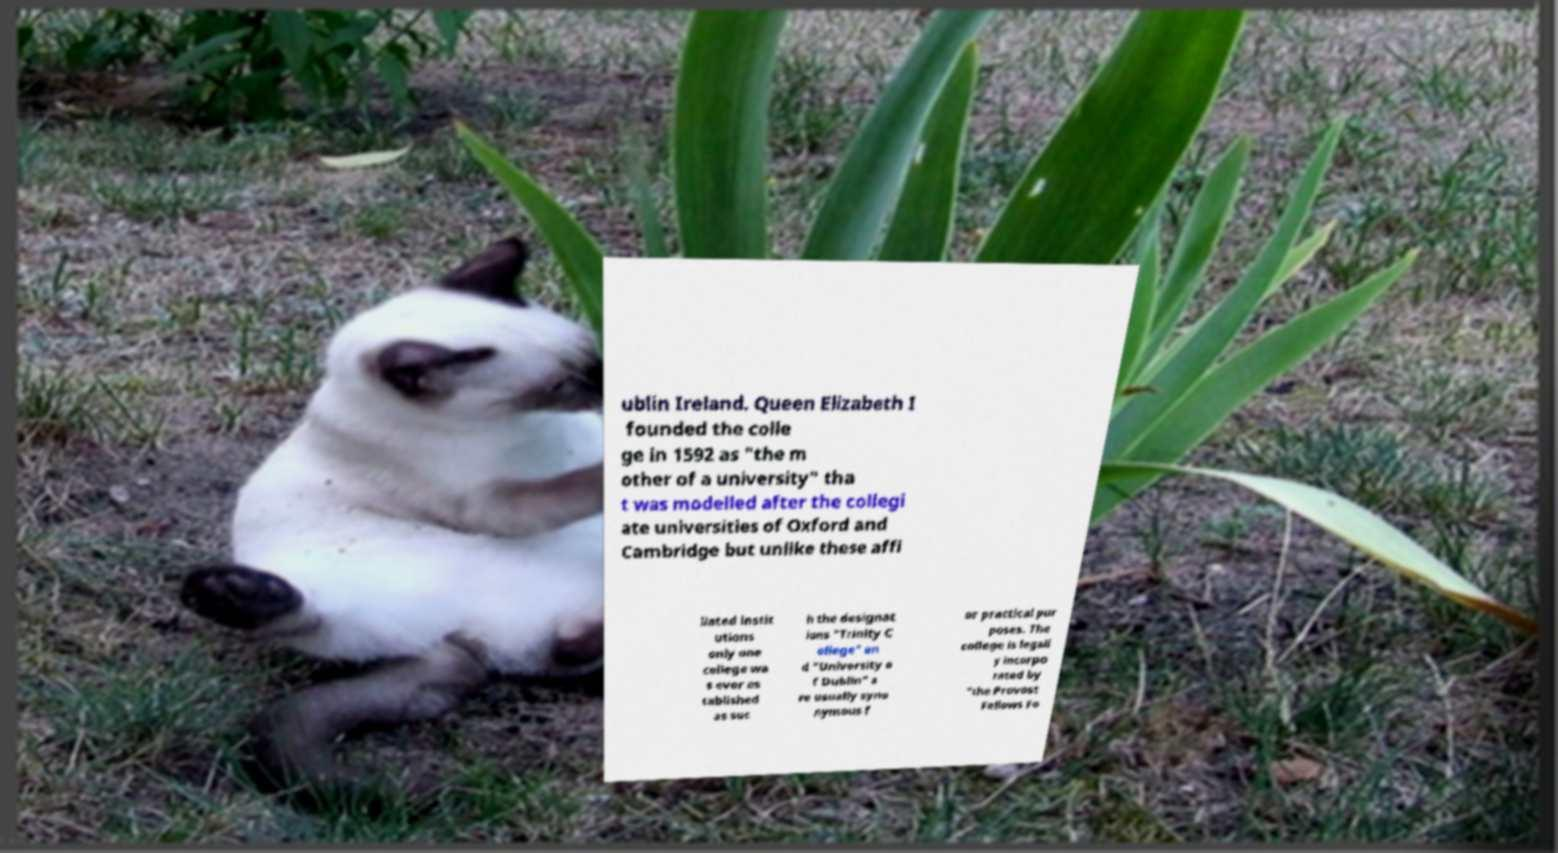Could you assist in decoding the text presented in this image and type it out clearly? ublin Ireland. Queen Elizabeth I founded the colle ge in 1592 as "the m other of a university" tha t was modelled after the collegi ate universities of Oxford and Cambridge but unlike these affi liated instit utions only one college wa s ever es tablished as suc h the designat ions "Trinity C ollege" an d "University o f Dublin" a re usually syno nymous f or practical pur poses. The college is legall y incorpo rated by "the Provost Fellows Fo 